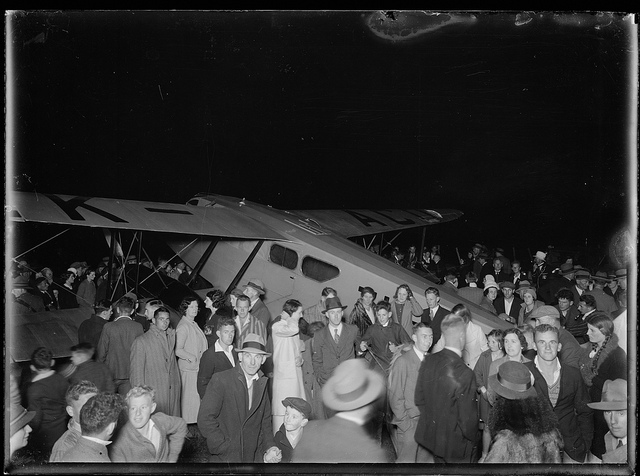<image>How old is this picture? I don't know. It can be decades or 70 to 85 years old. How old is this picture? I don't know how old this picture is. It can be around 70 years old, 80 years old, or even older. 